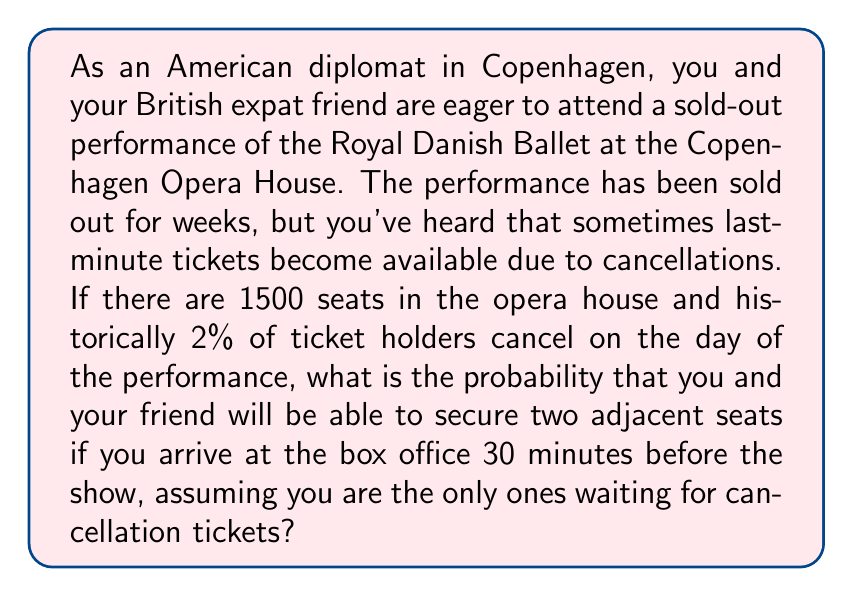Teach me how to tackle this problem. Let's approach this problem step-by-step:

1) First, we need to calculate the expected number of cancellations:
   $$\text{Expected cancellations} = 1500 \times 0.02 = 30$$

2) Now, we need to calculate the probability of getting at least two cancellations. We can use the binomial probability distribution for this.

3) The probability of getting exactly $k$ cancellations out of $n$ tickets, with a probability $p$ of each ticket being cancelled, is given by:

   $$P(X = k) = \binom{n}{k} p^k (1-p)^{n-k}$$

4) We need the probability of getting 2 or more cancellations. This is equal to 1 minus the probability of getting 0 or 1 cancellation:

   $$P(X \geq 2) = 1 - [P(X = 0) + P(X = 1)]$$

5) Calculating each term:
   $$P(X = 0) = \binom{1500}{0} 0.02^0 0.98^{1500} \approx 4.8131 \times 10^{-14}$$
   $$P(X = 1) = \binom{1500}{1} 0.02^1 0.98^{1499} \approx 1.4733 \times 10^{-12}$$

6) Therefore:
   $$P(X \geq 2) = 1 - (4.8131 \times 10^{-14} + 1.4733 \times 10^{-12}) \approx 0.999999998$$

7) However, we need two adjacent seats. The probability of any two cancelled seats being adjacent is approximately:
   $$\frac{1499}{1500 \times 1499/2} \approx 0.001333$$

8) The final probability is the product of these two probabilities:
   $$0.999999998 \times 0.001333 \approx 0.001333$$
Answer: The probability of securing two adjacent seats is approximately 0.001333 or about 0.13%. 